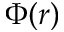<formula> <loc_0><loc_0><loc_500><loc_500>\Phi ( r )</formula> 